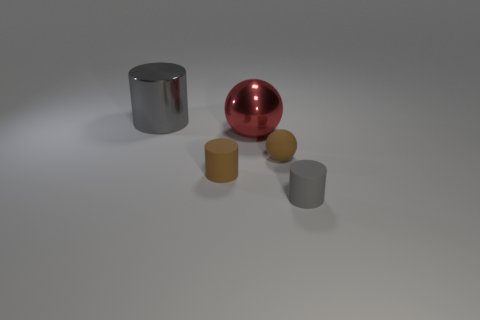What materials are the objects in the image made of? The objects seem to depict a variety of materials. The tall cylinder on the left has a metallic appearance suggesting it could be made of metal, while the shiny red sphere seems to simulate a reflective plastic or polished metal material. The two smaller cylinders could represent objects made from either a matte plastic or a non-reflective metal. 